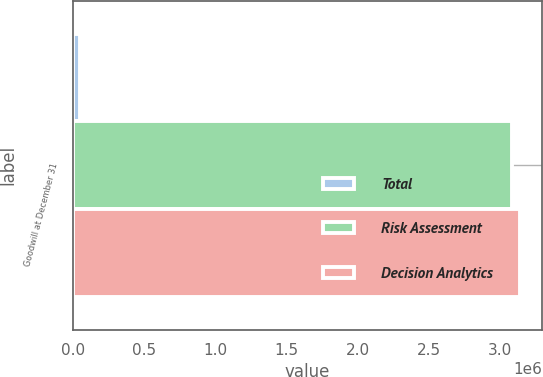<chart> <loc_0><loc_0><loc_500><loc_500><stacked_bar_chart><ecel><fcel>Goodwill at December 31<nl><fcel>Total<fcel>55555<nl><fcel>Risk Assessment<fcel>3.07927e+06<nl><fcel>Decision Analytics<fcel>3.13483e+06<nl></chart> 